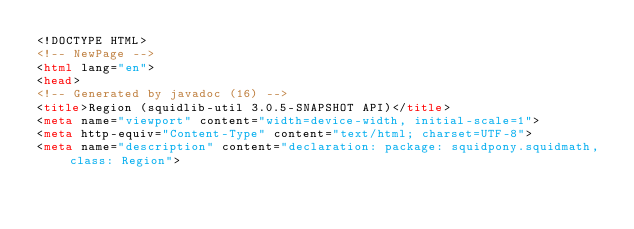<code> <loc_0><loc_0><loc_500><loc_500><_HTML_><!DOCTYPE HTML>
<!-- NewPage -->
<html lang="en">
<head>
<!-- Generated by javadoc (16) -->
<title>Region (squidlib-util 3.0.5-SNAPSHOT API)</title>
<meta name="viewport" content="width=device-width, initial-scale=1">
<meta http-equiv="Content-Type" content="text/html; charset=UTF-8">
<meta name="description" content="declaration: package: squidpony.squidmath, class: Region"></code> 